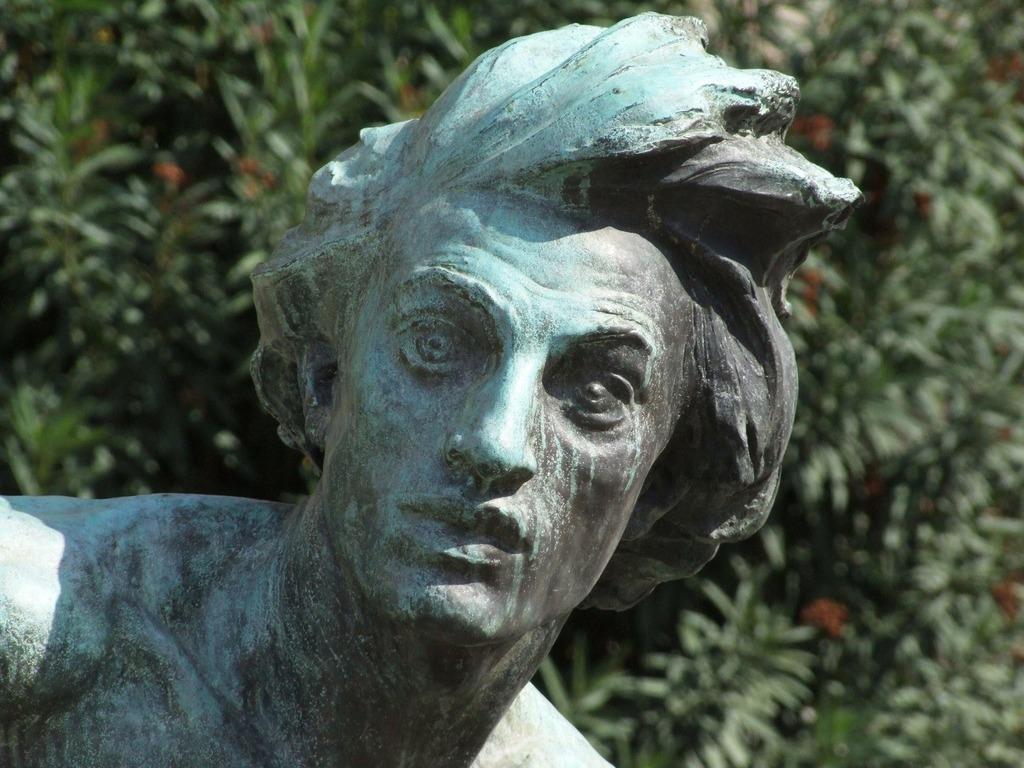How would you summarize this image in a sentence or two? This picture shows a statue of a man and we see trees. 